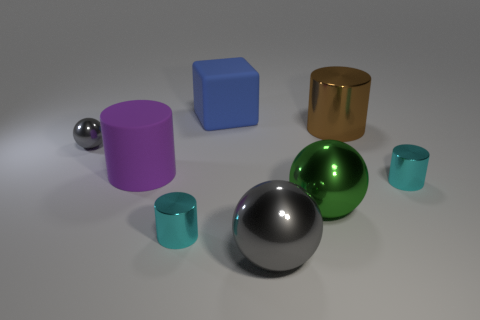Add 1 small yellow shiny cylinders. How many objects exist? 9 Subtract all cyan cylinders. How many cylinders are left? 2 Subtract all blocks. How many objects are left? 7 Subtract 1 blocks. How many blocks are left? 0 Subtract all small blue metallic cylinders. Subtract all brown shiny cylinders. How many objects are left? 7 Add 5 brown metallic objects. How many brown metallic objects are left? 6 Add 8 big rubber cylinders. How many big rubber cylinders exist? 9 Subtract all big purple rubber cylinders. How many cylinders are left? 3 Subtract 0 green cubes. How many objects are left? 8 Subtract all red cylinders. Subtract all cyan spheres. How many cylinders are left? 4 